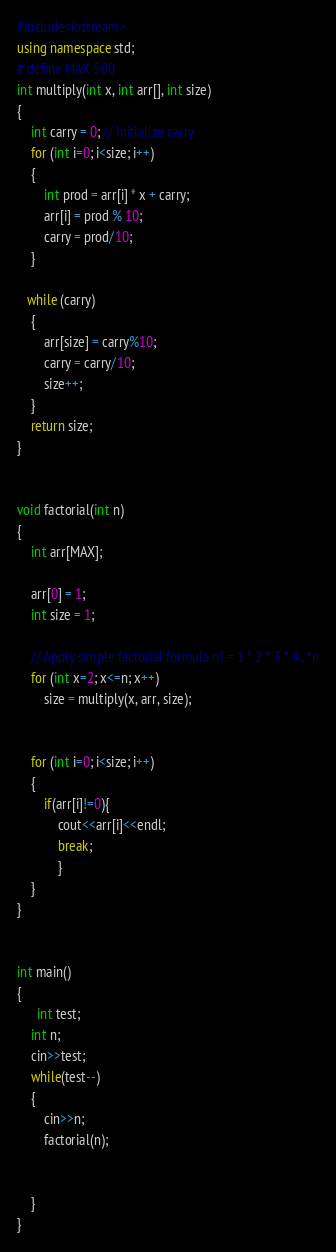<code> <loc_0><loc_0><loc_500><loc_500><_C++_>#include<iostream>
using namespace std;
# define MAX 500
int multiply(int x, int arr[], int size)
{
	int carry = 0; // Initialize carry
    for (int i=0; i<size; i++)
	{
		int prod = arr[i] * x + carry;
		arr[i] = prod % 10;
		carry = prod/10;
	}

   while (carry)
	{
		arr[size] = carry%10;
		carry = carry/10;
		size++;
	}
	return size;
}


void factorial(int n)
{
	int arr[MAX];

	arr[0] = 1;
	int size = 1;

	// Apply simple factorial formula n! = 1 * 2 * 3 * 4...*n
	for (int x=2; x<=n; x++)
		size = multiply(x, arr, size);


	for (int i=0; i<size; i++)
    {
        if(arr[i]!=0){
            cout<<arr[i]<<endl;
            break;
            }
    }
}


int main()
{
      int test;
    int n;
    cin>>test;
    while(test--)
    {
        cin>>n;
        factorial(n);


    }
}

</code> 